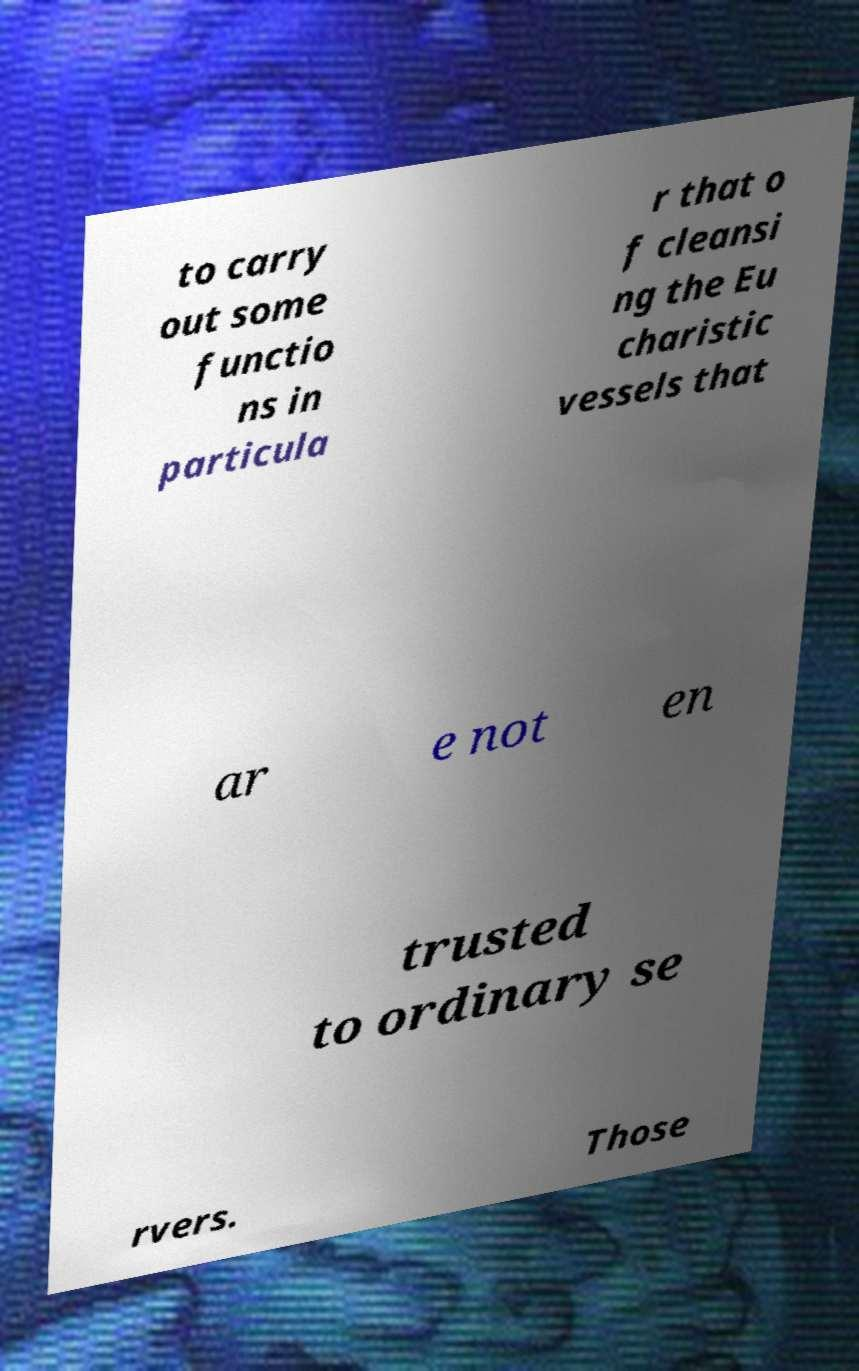There's text embedded in this image that I need extracted. Can you transcribe it verbatim? to carry out some functio ns in particula r that o f cleansi ng the Eu charistic vessels that ar e not en trusted to ordinary se rvers. Those 